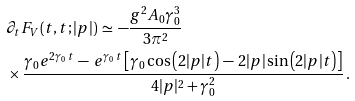Convert formula to latex. <formula><loc_0><loc_0><loc_500><loc_500>& \partial _ { t } F _ { V } ( t , t ; | { p } | ) \, \simeq \, - \frac { g ^ { 2 } A _ { 0 } \gamma _ { 0 } ^ { 3 } } { 3 \pi ^ { 2 } } \\ & \times \frac { \gamma _ { 0 } e ^ { 2 \gamma _ { 0 } \, t } \, - \, e ^ { \gamma _ { 0 } \, t } \left [ \gamma _ { 0 } \cos \left ( 2 | { p } | t \right ) \, - \, 2 | p | \sin \left ( 2 | { p } | t \right ) \right ] } { 4 | { p } | ^ { 2 } + \gamma _ { 0 } ^ { 2 } } \, .</formula> 